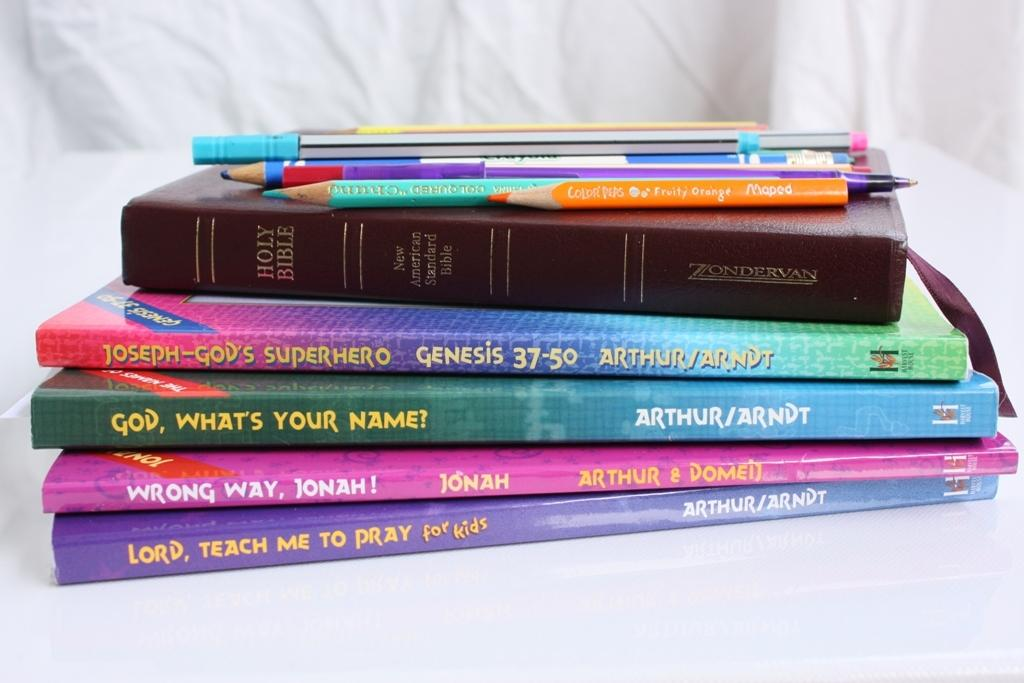<image>
Offer a succinct explanation of the picture presented. A stack of children's books including the Holy Bible. 